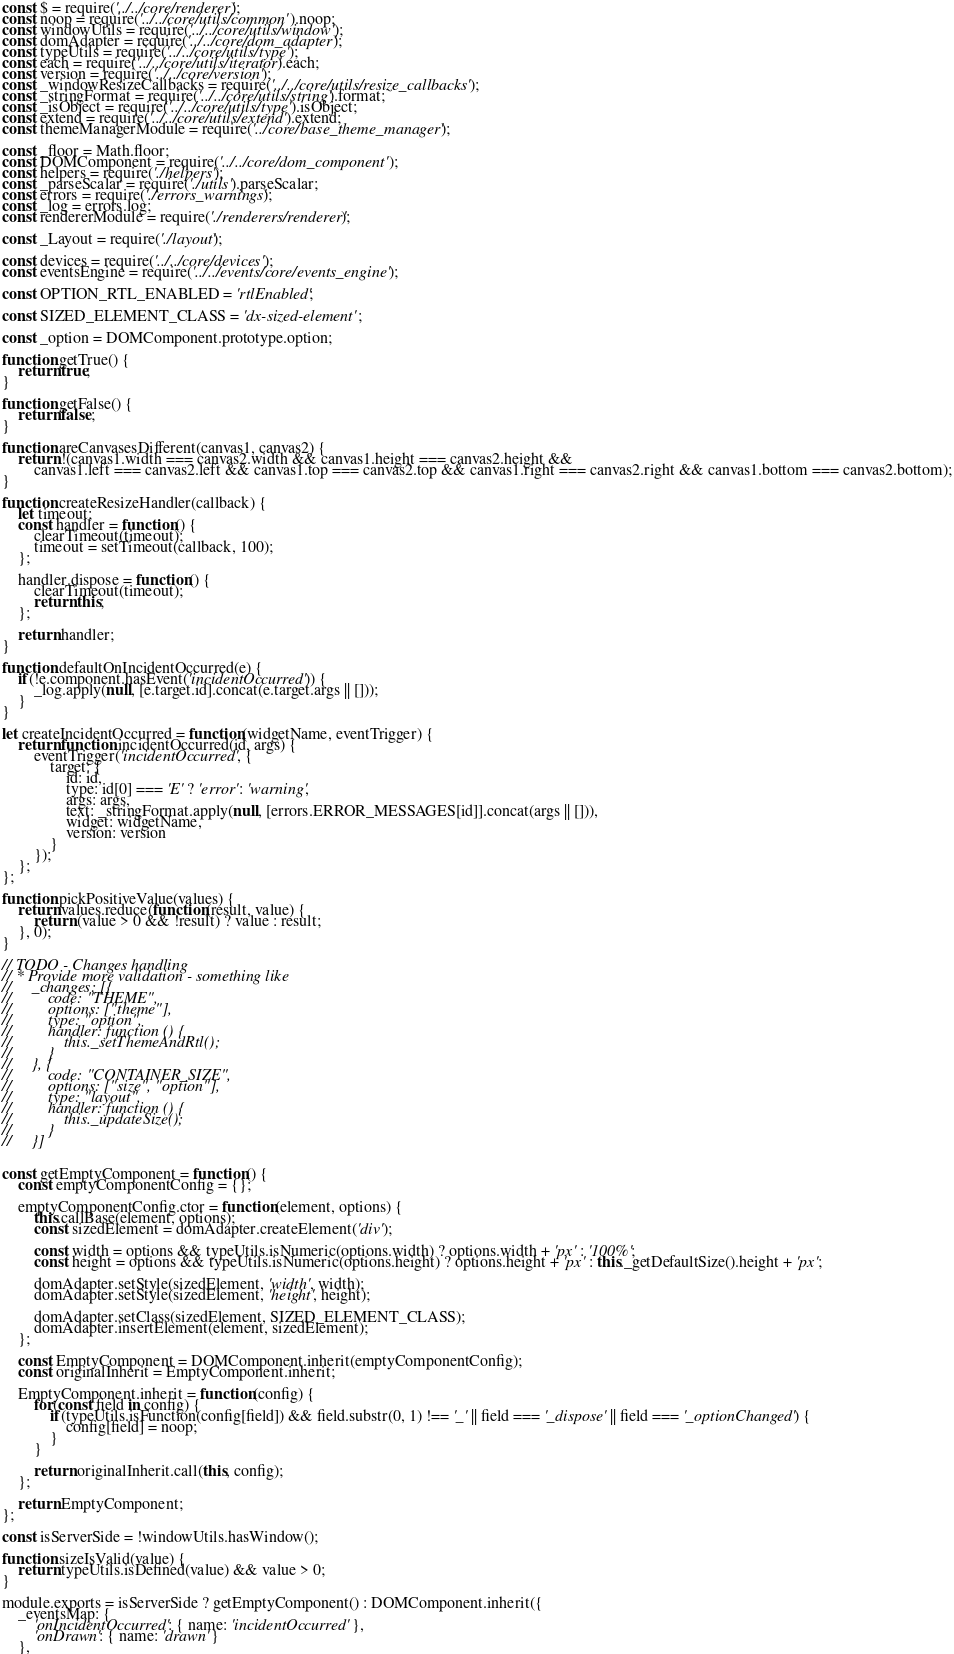<code> <loc_0><loc_0><loc_500><loc_500><_JavaScript_>const $ = require('../../core/renderer');
const noop = require('../../core/utils/common').noop;
const windowUtils = require('../../core/utils/window');
const domAdapter = require('../../core/dom_adapter');
const typeUtils = require('../../core/utils/type');
const each = require('../../core/utils/iterator').each;
const version = require('../../core/version');
const _windowResizeCallbacks = require('../../core/utils/resize_callbacks');
const _stringFormat = require('../../core/utils/string').format;
const _isObject = require('../../core/utils/type').isObject;
const extend = require('../../core/utils/extend').extend;
const themeManagerModule = require('../core/base_theme_manager');

const _floor = Math.floor;
const DOMComponent = require('../../core/dom_component');
const helpers = require('./helpers');
const _parseScalar = require('./utils').parseScalar;
const errors = require('./errors_warnings');
const _log = errors.log;
const rendererModule = require('./renderers/renderer');

const _Layout = require('./layout');

const devices = require('../../core/devices');
const eventsEngine = require('../../events/core/events_engine');

const OPTION_RTL_ENABLED = 'rtlEnabled';

const SIZED_ELEMENT_CLASS = 'dx-sized-element';

const _option = DOMComponent.prototype.option;

function getTrue() {
    return true;
}

function getFalse() {
    return false;
}

function areCanvasesDifferent(canvas1, canvas2) {
    return !(canvas1.width === canvas2.width && canvas1.height === canvas2.height &&
        canvas1.left === canvas2.left && canvas1.top === canvas2.top && canvas1.right === canvas2.right && canvas1.bottom === canvas2.bottom);
}

function createResizeHandler(callback) {
    let timeout;
    const handler = function() {
        clearTimeout(timeout);
        timeout = setTimeout(callback, 100);
    };

    handler.dispose = function() {
        clearTimeout(timeout);
        return this;
    };

    return handler;
}

function defaultOnIncidentOccurred(e) {
    if(!e.component.hasEvent('incidentOccurred')) {
        _log.apply(null, [e.target.id].concat(e.target.args || []));
    }
}

let createIncidentOccurred = function(widgetName, eventTrigger) {
    return function incidentOccurred(id, args) {
        eventTrigger('incidentOccurred', {
            target: {
                id: id,
                type: id[0] === 'E' ? 'error' : 'warning',
                args: args,
                text: _stringFormat.apply(null, [errors.ERROR_MESSAGES[id]].concat(args || [])),
                widget: widgetName,
                version: version
            }
        });
    };
};

function pickPositiveValue(values) {
    return values.reduce(function(result, value) {
        return (value > 0 && !result) ? value : result;
    }, 0);
}

// TODO - Changes handling
// * Provide more validation - something like
//     _changes: [{
//         code: "THEME",
//         options: ["theme"],
//         type: "option",
//         handler: function () {
//             this._setThemeAndRtl();
//         }
//     }, {
//         code: "CONTAINER_SIZE",
//         options: ["size", "option"],
//         type: "layout",
//         handler: function () {
//             this._updateSize();
//         }
//     }]


const getEmptyComponent = function() {
    const emptyComponentConfig = {};

    emptyComponentConfig.ctor = function(element, options) {
        this.callBase(element, options);
        const sizedElement = domAdapter.createElement('div');

        const width = options && typeUtils.isNumeric(options.width) ? options.width + 'px' : '100%';
        const height = options && typeUtils.isNumeric(options.height) ? options.height + 'px' : this._getDefaultSize().height + 'px';

        domAdapter.setStyle(sizedElement, 'width', width);
        domAdapter.setStyle(sizedElement, 'height', height);

        domAdapter.setClass(sizedElement, SIZED_ELEMENT_CLASS);
        domAdapter.insertElement(element, sizedElement);
    };

    const EmptyComponent = DOMComponent.inherit(emptyComponentConfig);
    const originalInherit = EmptyComponent.inherit;

    EmptyComponent.inherit = function(config) {
        for(const field in config) {
            if(typeUtils.isFunction(config[field]) && field.substr(0, 1) !== '_' || field === '_dispose' || field === '_optionChanged') {
                config[field] = noop;
            }
        }

        return originalInherit.call(this, config);
    };

    return EmptyComponent;
};

const isServerSide = !windowUtils.hasWindow();

function sizeIsValid(value) {
    return typeUtils.isDefined(value) && value > 0;
}

module.exports = isServerSide ? getEmptyComponent() : DOMComponent.inherit({
    _eventsMap: {
        'onIncidentOccurred': { name: 'incidentOccurred' },
        'onDrawn': { name: 'drawn' }
    },
</code> 